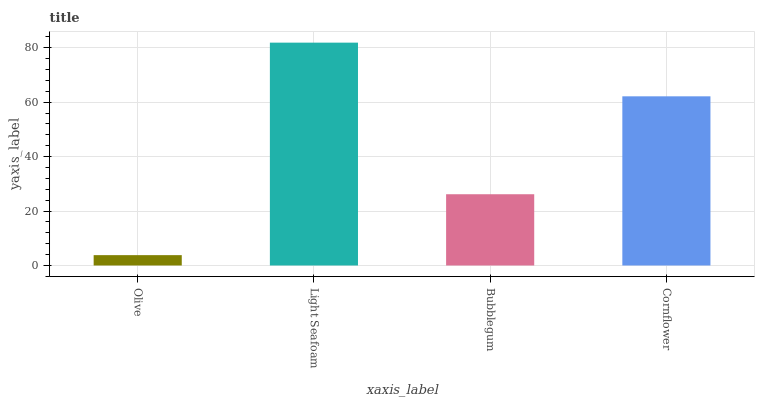Is Olive the minimum?
Answer yes or no. Yes. Is Light Seafoam the maximum?
Answer yes or no. Yes. Is Bubblegum the minimum?
Answer yes or no. No. Is Bubblegum the maximum?
Answer yes or no. No. Is Light Seafoam greater than Bubblegum?
Answer yes or no. Yes. Is Bubblegum less than Light Seafoam?
Answer yes or no. Yes. Is Bubblegum greater than Light Seafoam?
Answer yes or no. No. Is Light Seafoam less than Bubblegum?
Answer yes or no. No. Is Cornflower the high median?
Answer yes or no. Yes. Is Bubblegum the low median?
Answer yes or no. Yes. Is Bubblegum the high median?
Answer yes or no. No. Is Olive the low median?
Answer yes or no. No. 